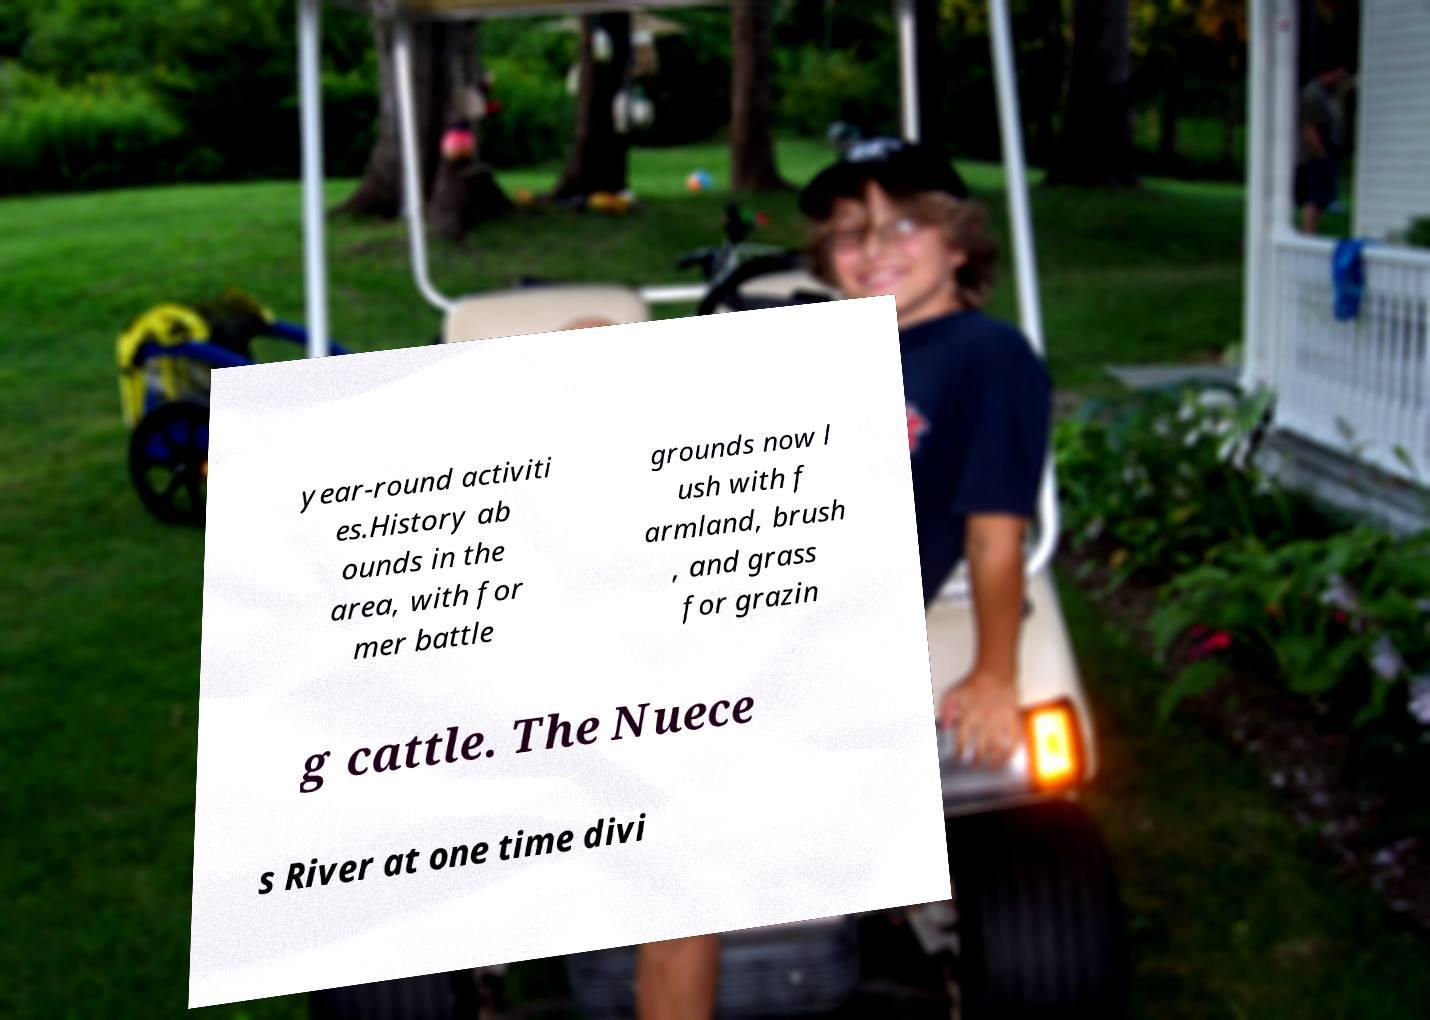I need the written content from this picture converted into text. Can you do that? year-round activiti es.History ab ounds in the area, with for mer battle grounds now l ush with f armland, brush , and grass for grazin g cattle. The Nuece s River at one time divi 